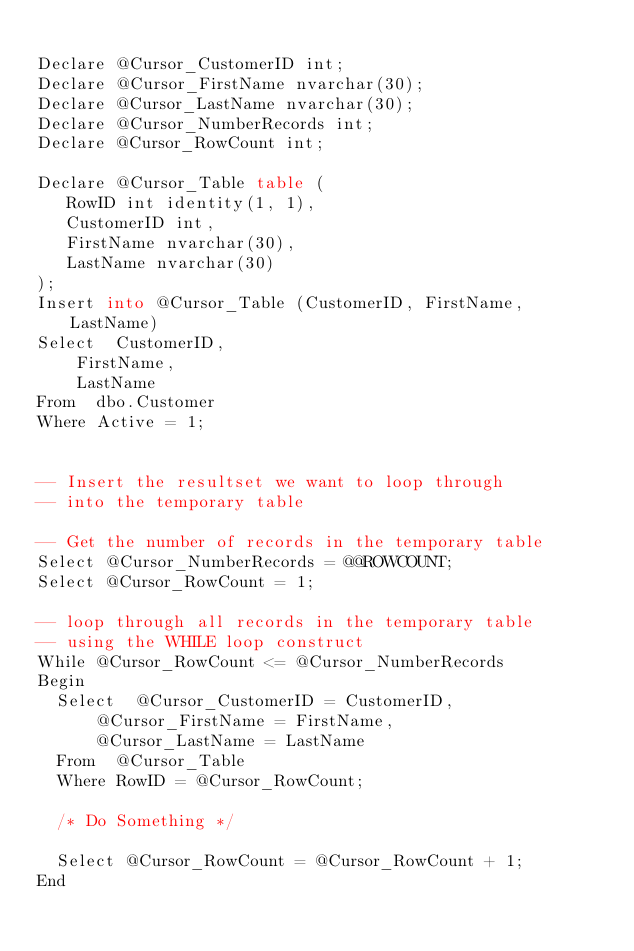Convert code to text. <code><loc_0><loc_0><loc_500><loc_500><_SQL_>
Declare @Cursor_CustomerID int;
Declare @Cursor_FirstName nvarchar(30);
Declare @Cursor_LastName nvarchar(30);
Declare @Cursor_NumberRecords int;
Declare @Cursor_RowCount int;

Declare @Cursor_Table table (
	 RowID int identity(1, 1), 
	 CustomerID int,
	 FirstName nvarchar(30),
	 LastName nvarchar(30)
);
Insert into @Cursor_Table (CustomerID, FirstName, LastName)
Select	CustomerID, 
		FirstName, 
		LastName
From	dbo.Customer
Where	Active = 1; 


-- Insert the resultset we want to loop through
-- into the temporary table

-- Get the number of records in the temporary table
Select @Cursor_NumberRecords = @@ROWCOUNT;
Select @Cursor_RowCount = 1;

-- loop through all records in the temporary table
-- using the WHILE loop construct
While @Cursor_RowCount <= @Cursor_NumberRecords
Begin
	Select  @Cursor_CustomerID = CustomerID, 
			@Cursor_FirstName = FirstName, 
			@Cursor_LastName = LastName 
	From	@Cursor_Table
	Where	RowID = @Cursor_RowCount;

	/* Do Something */

	Select @Cursor_RowCount = @Cursor_RowCount + 1;
End
</code> 